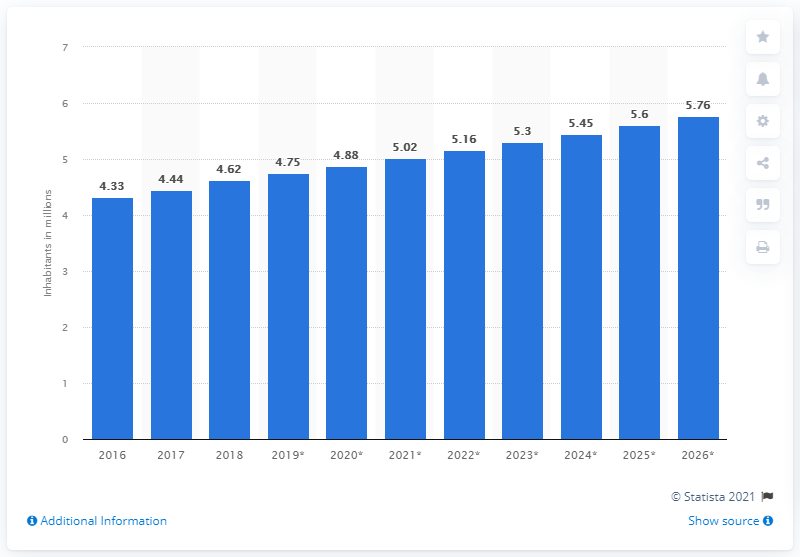Draw attention to some important aspects in this diagram. Between 2016 and 2026, Kuwait's population increased from 2016 to 2026. In 2018, the population of Kuwait was approximately 4.62 million. 